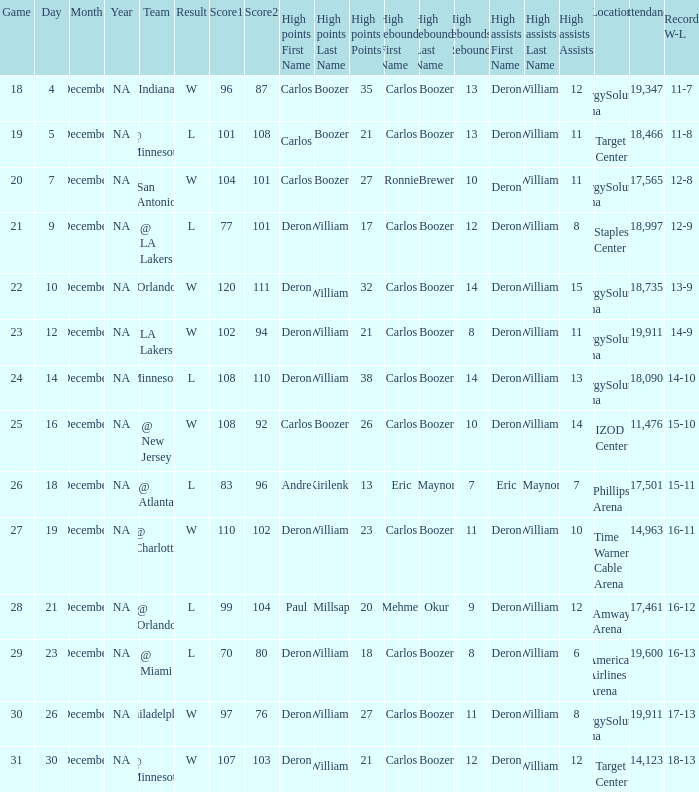What's the number of the game in which Carlos Boozer (8) did the high rebounds? 29.0. 